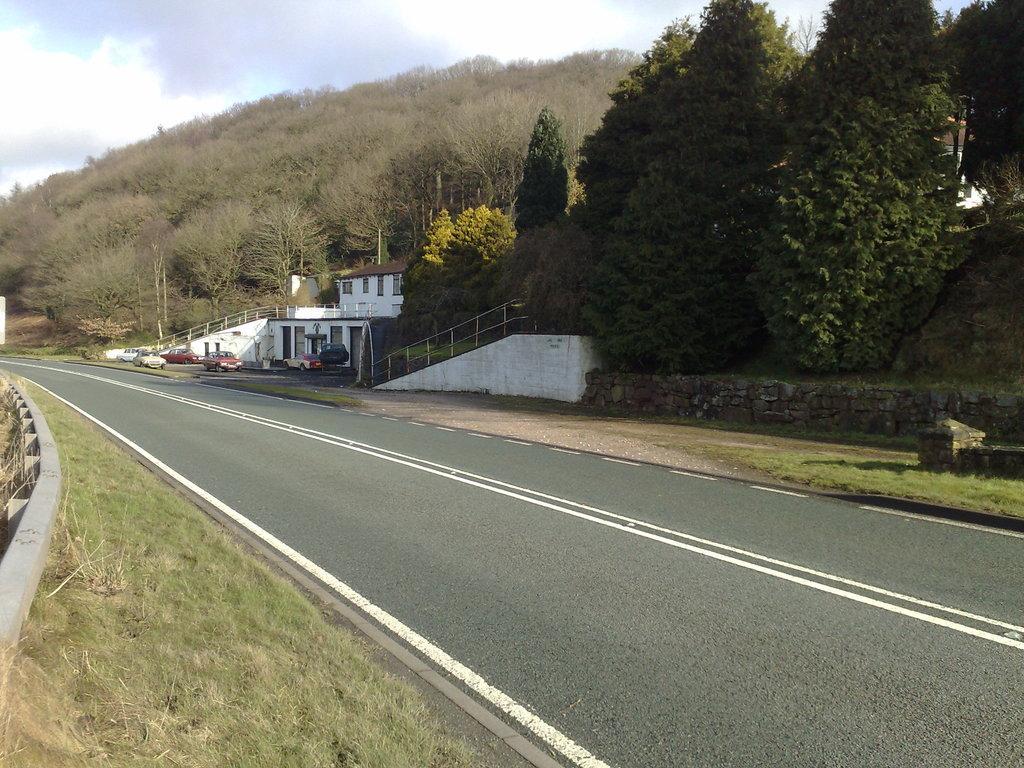Could you give a brief overview of what you see in this image? This picture is clicked outside. In the foreground we can see the grass and the concrete road. In the center we can see the house, metal rods, vehicles and many other objects and we can see the trees. In the background we can see the sky. 